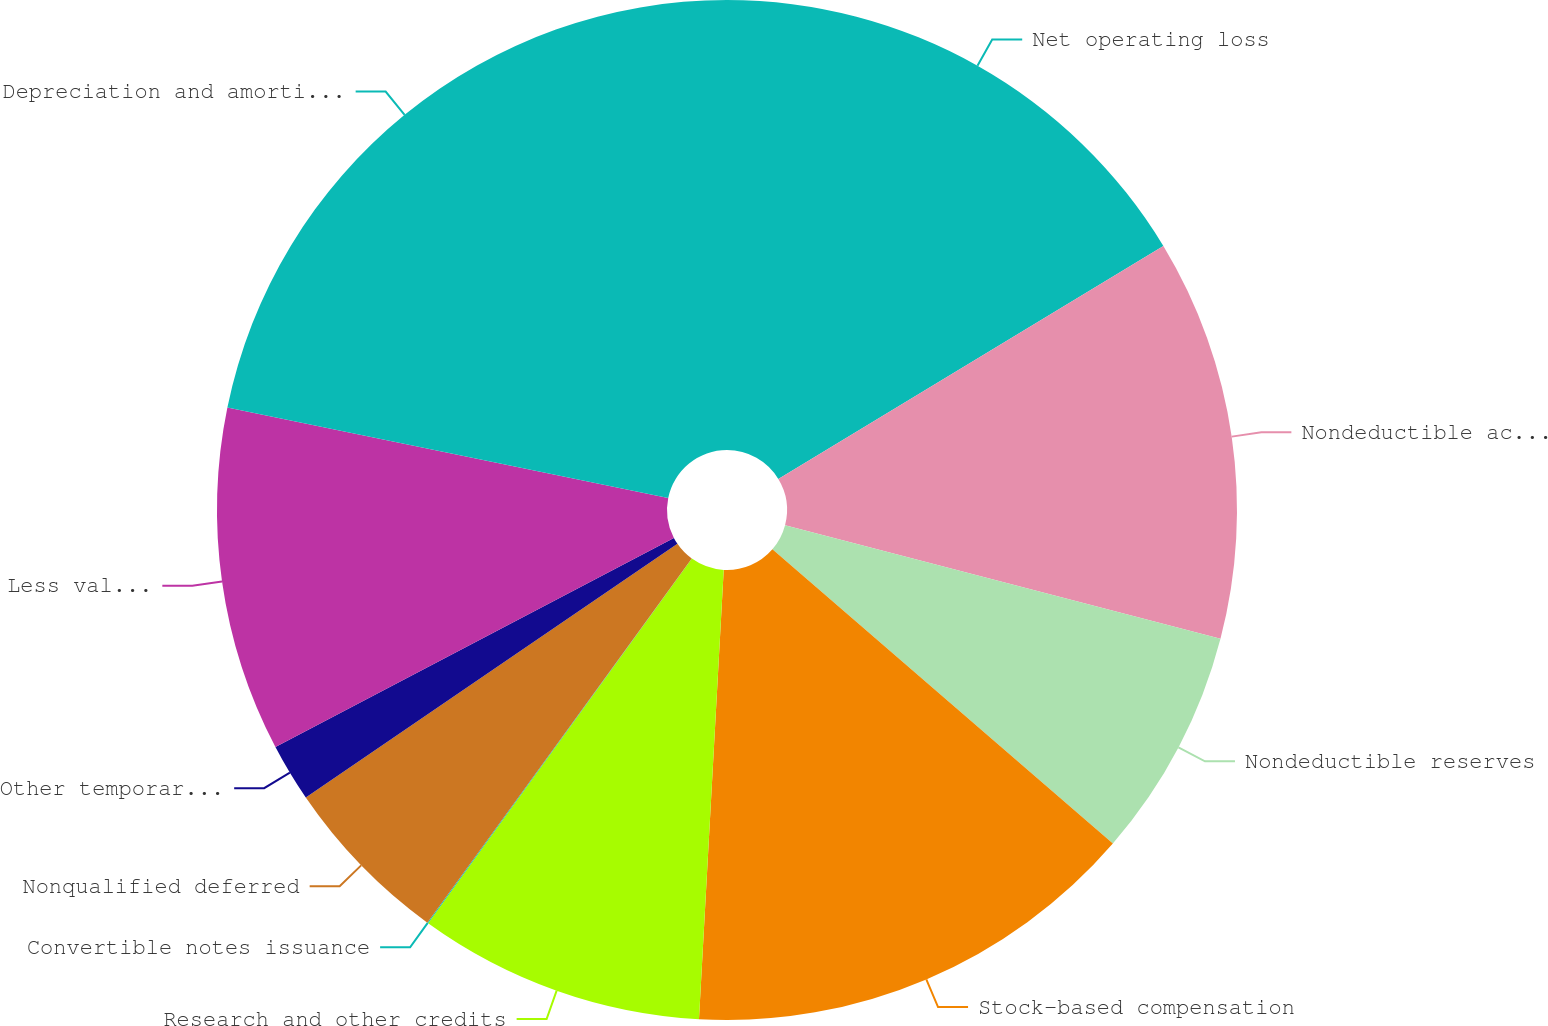<chart> <loc_0><loc_0><loc_500><loc_500><pie_chart><fcel>Net operating loss<fcel>Nondeductible accruals<fcel>Nondeductible reserves<fcel>Stock-based compensation<fcel>Research and other credits<fcel>Convertible notes issuance<fcel>Nonqualified deferred<fcel>Other temporary differences<fcel>Less valuation allowance<fcel>Depreciation and amortization<nl><fcel>16.34%<fcel>12.72%<fcel>7.28%<fcel>14.53%<fcel>9.09%<fcel>0.03%<fcel>5.47%<fcel>1.84%<fcel>10.91%<fcel>21.78%<nl></chart> 